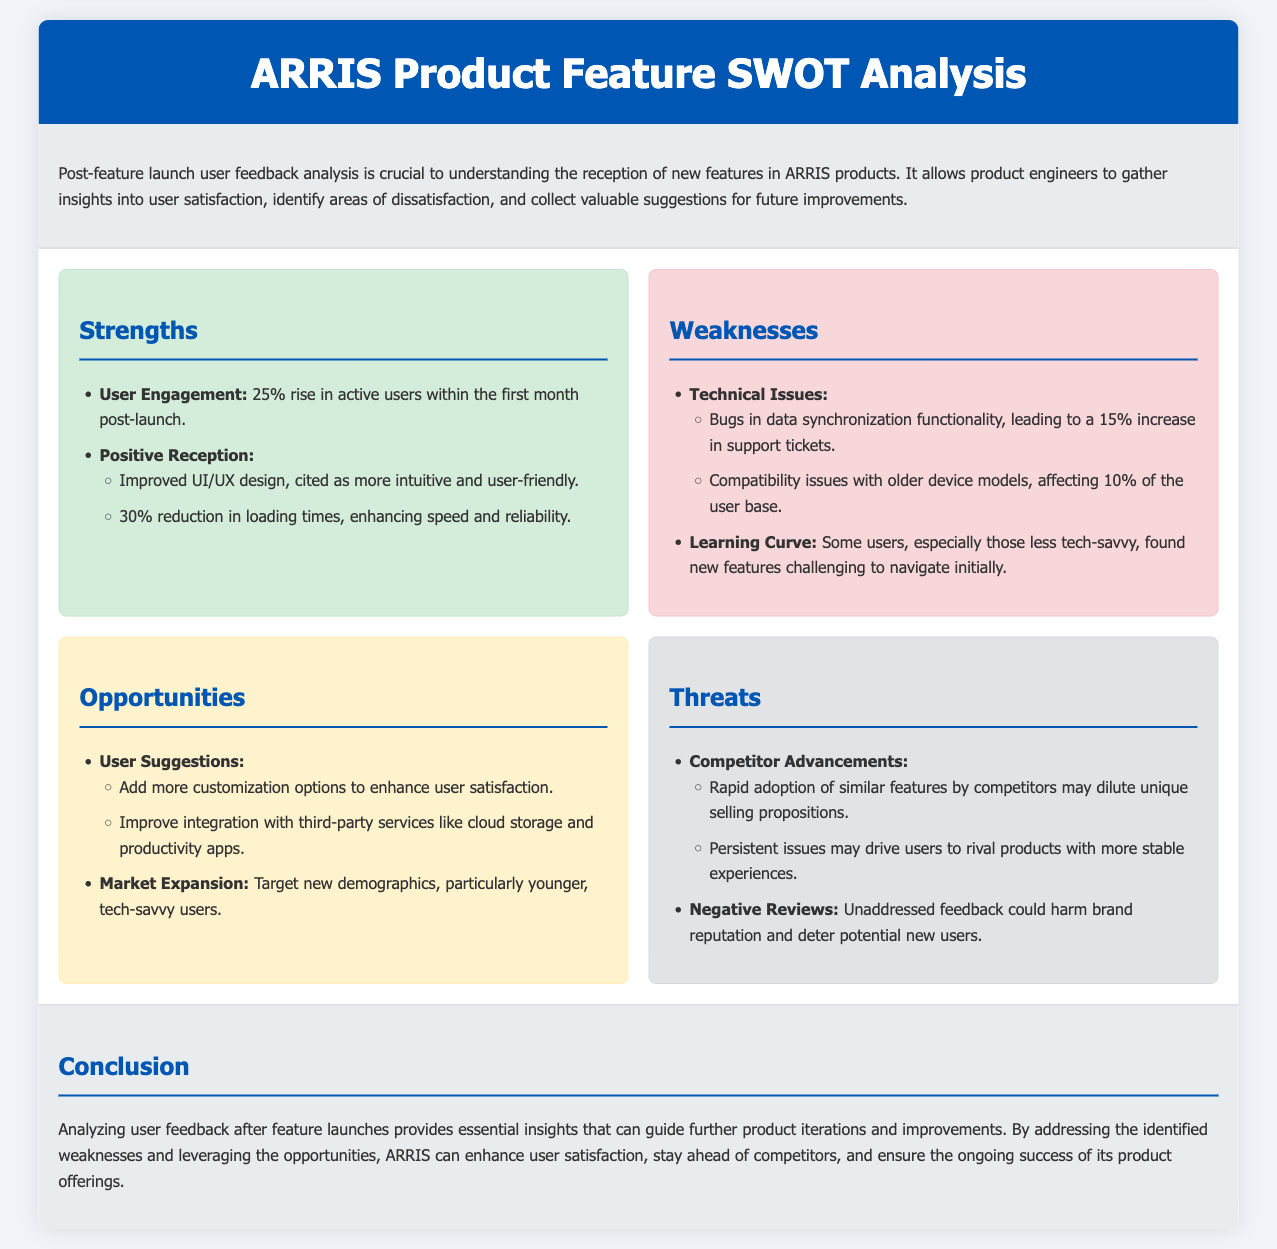What was the rise in active users post-launch? The document states there was a 25% rise in active users within the first month post-launch.
Answer: 25% What technical issue caused an increase in support tickets? The document mentions bugs in data synchronization functionality, leading to a 15% increase in support tickets.
Answer: Bugs in data synchronization What percentage of users experienced compatibility issues? The document specifies that compatibility issues affected 10% of the user base.
Answer: 10% What is one suggestion users have for improving the product? The document lists adding more customization options as a suggestion from users to enhance satisfaction.
Answer: More customization options What are two threats mentioned related to competitors? The document highlights rapid adoption of similar features by competitors and persistent issues driving users to rival products as threats.
Answer: Competitor advancements How much was the reduction in loading times after the feature launch? The document indicates a 30% reduction in loading times, improving speed and reliability.
Answer: 30% Which demographic is suggested for market expansion? The document points to targeting younger, tech-savvy users for market expansion.
Answer: Younger, tech-savvy users What is the main purpose of a SWOT analysis in this context? The document indicates that analyzing user feedback after feature launches guides product iterations and improvements.
Answer: Guide product iterations During which time frame was the rise in active users observed? The document specifies that the 25% rise in active users was observed within the first month post-launch.
Answer: First month post-launch 